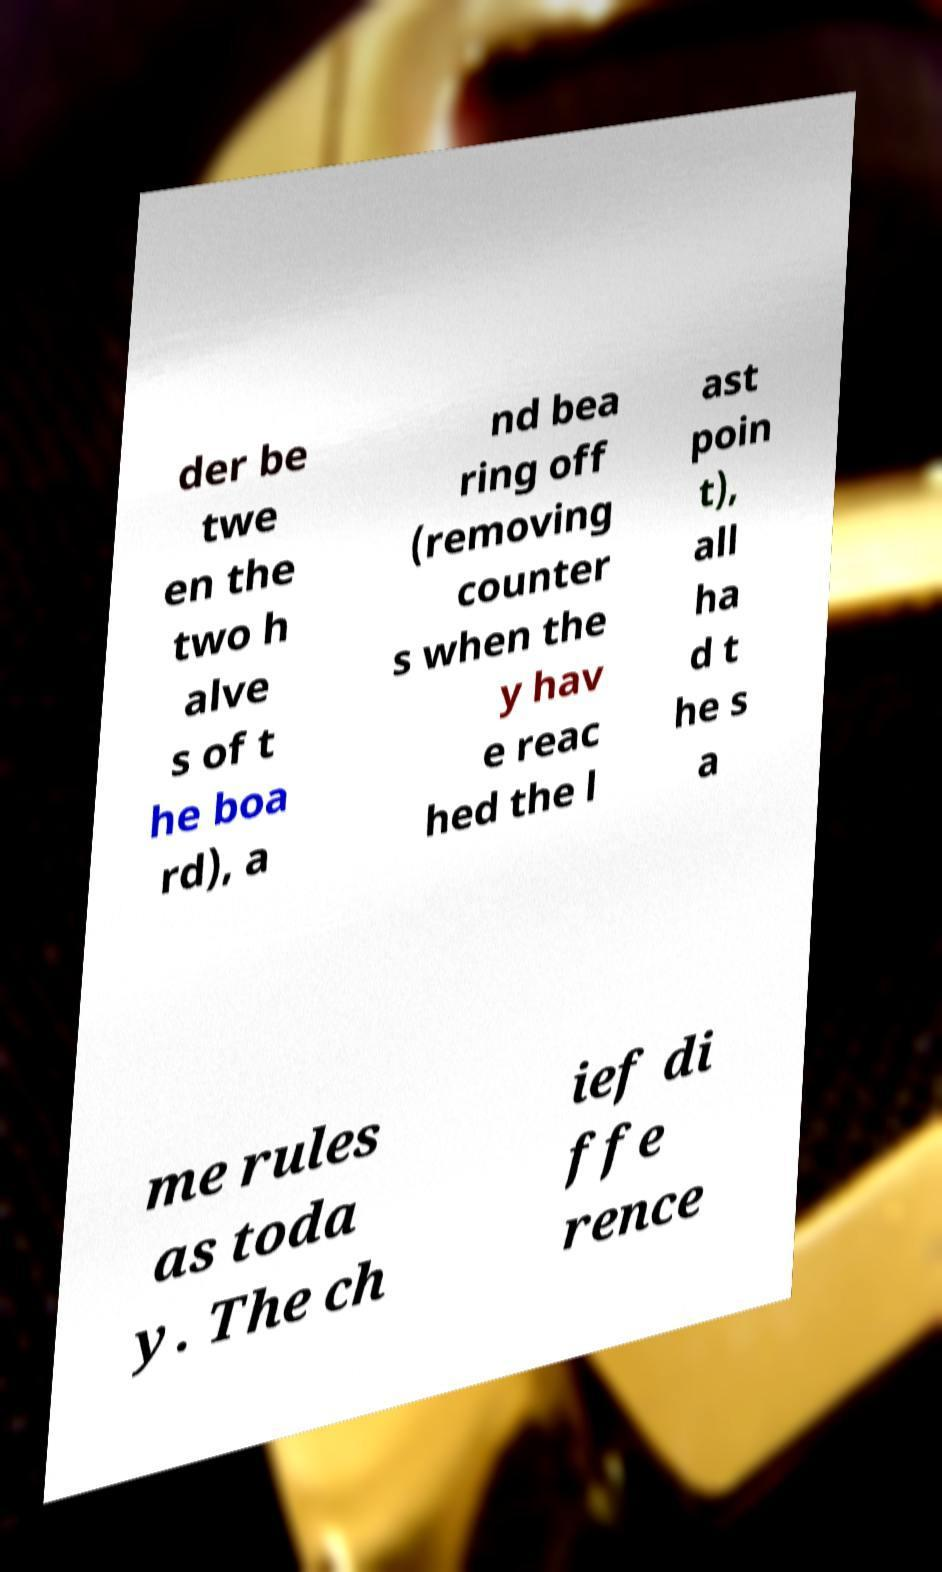Could you extract and type out the text from this image? der be twe en the two h alve s of t he boa rd), a nd bea ring off (removing counter s when the y hav e reac hed the l ast poin t), all ha d t he s a me rules as toda y. The ch ief di ffe rence 